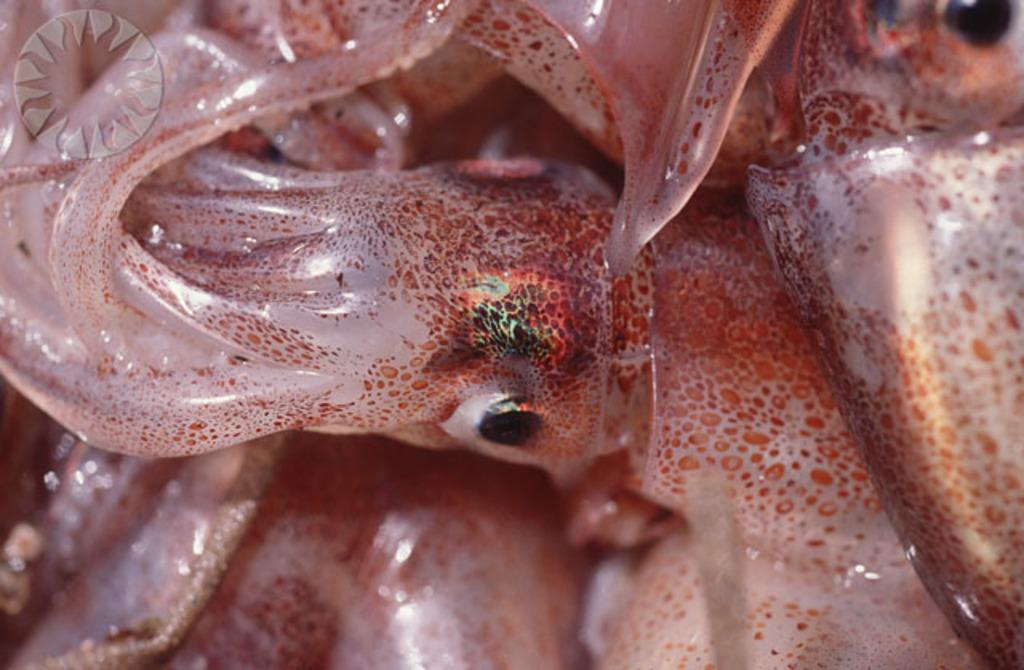What is the main subject of the image? The main subject of the image is a picture of an octopus. What type of wax can be seen melting in the market in the image? There is no mention of wax, melting or a market in the image; it only features a picture of an octopus. 